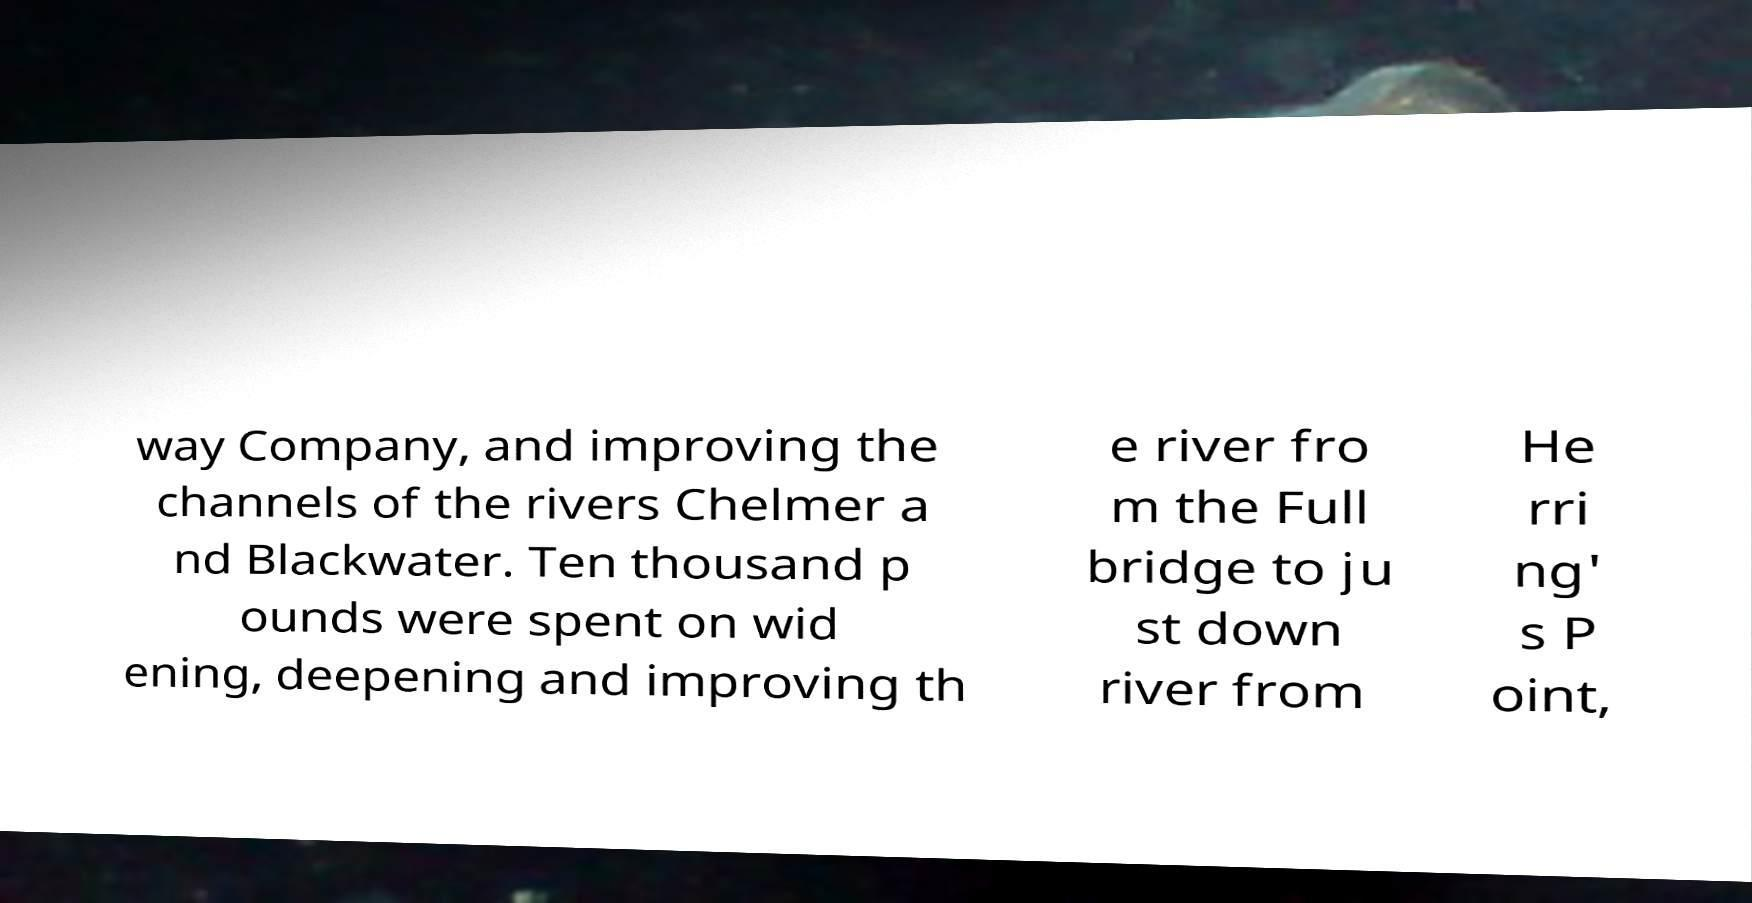Please read and relay the text visible in this image. What does it say? way Company, and improving the channels of the rivers Chelmer a nd Blackwater. Ten thousand p ounds were spent on wid ening, deepening and improving th e river fro m the Full bridge to ju st down river from He rri ng' s P oint, 